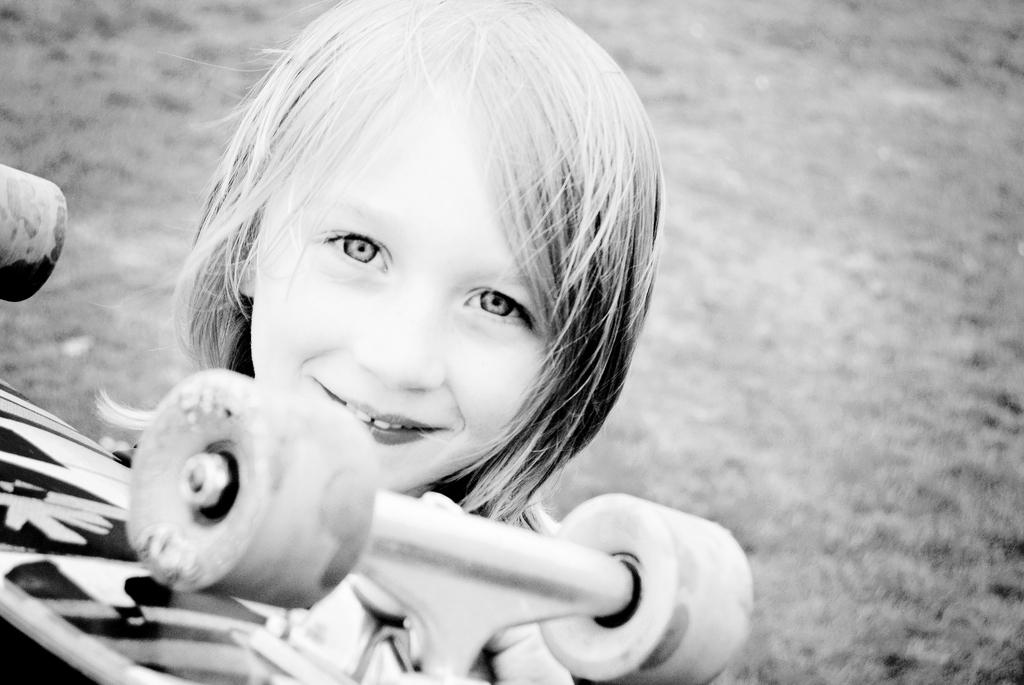What is the main subject of the image? The main subject of the image is a child. What is the child doing in the image? The child is holding an object. How many eggs are visible in the image? There are no eggs present in the image. What type of push is the child performing in the image? The image does not show the child pushing anything; they are simply holding an object. 